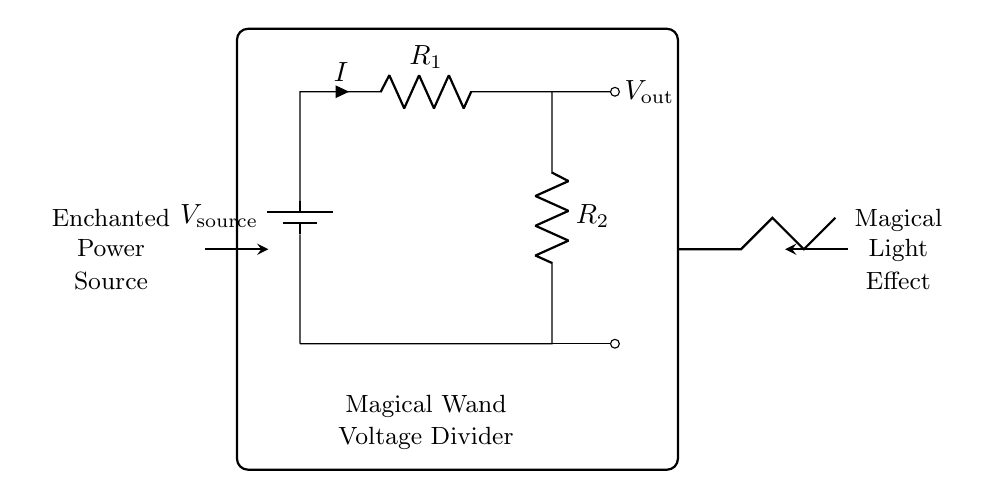What type of circuit is presented? The circuit is a voltage divider, which divides the input voltage across two resistors.
Answer: Voltage Divider What is the role of the battery in this circuit? The battery serves as the power source, providing the input voltage needed for the voltage divider to function.
Answer: Power Source What does the output voltage depend on? The output voltage depends on the values of the resistors R1 and R2 according to the voltage divider formula.
Answer: R1 and R2 values What is the relationship between the current and the resistors? The current is the same through both resistors in a series circuit, as they are connected end-to-end.
Answer: Same current What is the output voltage symbol in the diagram? The output voltage is indicated by the symbol Vout, which represents the voltage measured across R2.
Answer: Vout How can the output voltage be calculated in a voltage divider? The output voltage can be calculated using the formula Vout = Vin * (R2 / (R1 + R2)), where Vin is the input voltage across the divider.
Answer: Vout = Vin * (R2 / (R1 + R2)) What happens to the output voltage if R1 increases? If R1 increases, the output voltage Vout decreases, since a higher resistance causes a larger voltage drop across R1 relative to R2.
Answer: Vout decreases 